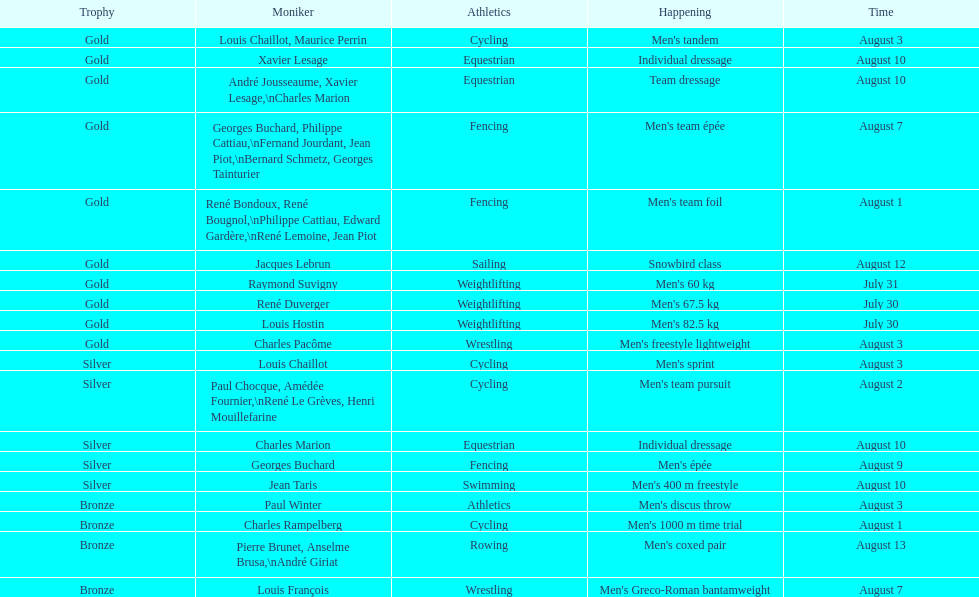What sport did louis challiot win the same medal as paul chocque in? Cycling. 